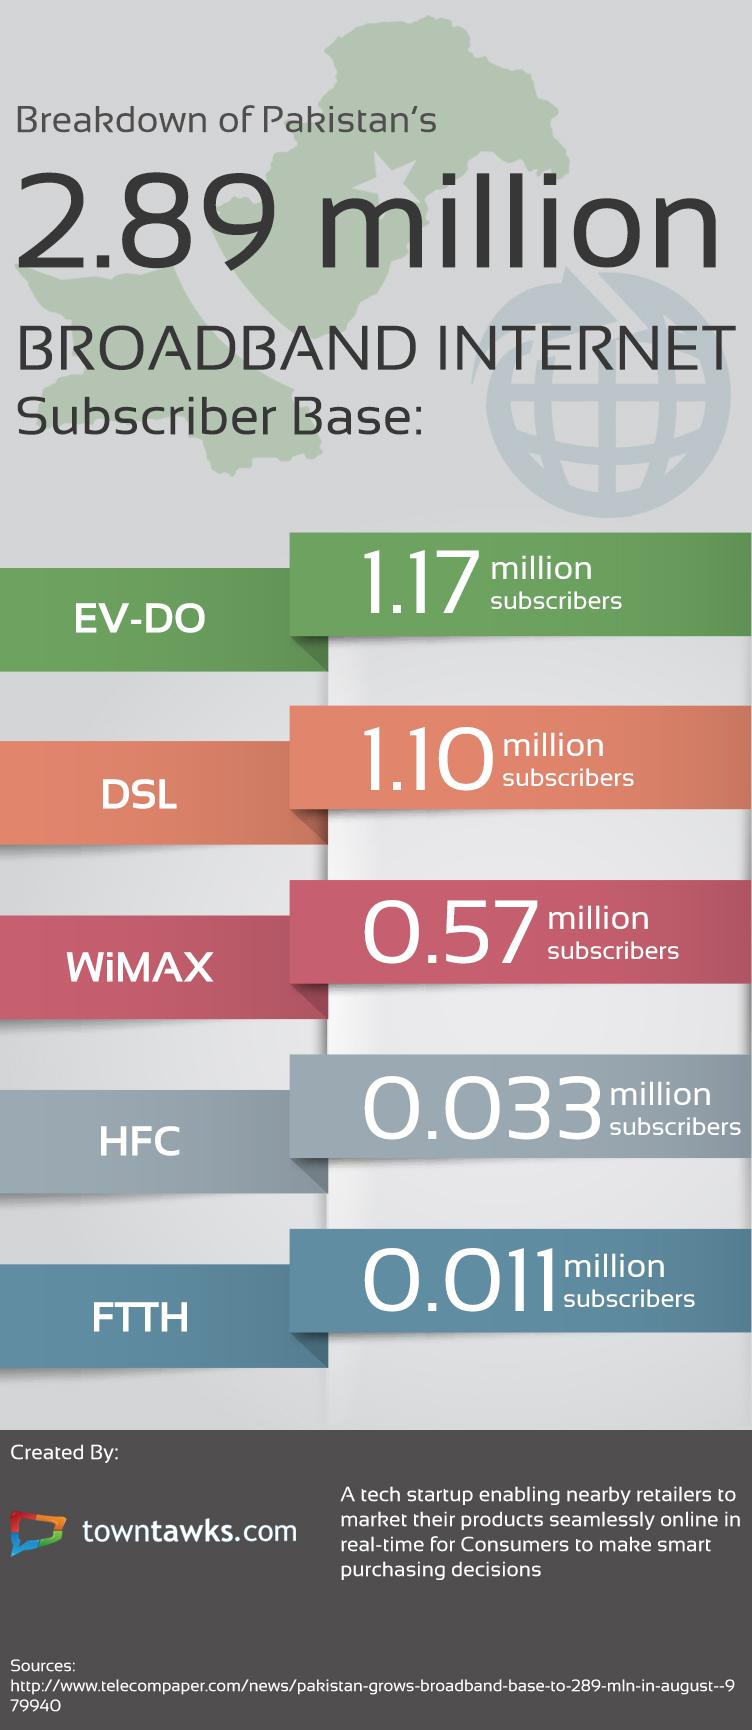List a handful of essential elements in this visual. HFC broadband internet connection type has the second lowest number of subscribers in Pakistan. The type of broadband internet connection with the highest number of subscribers in Pakistan is EV-DO. FTTH is the type of broadband internet connection in Pakistan with the least number of subscribers. DSL is the second most popular type of broadband internet connection in Pakistan, with the highest number of subscribers. 